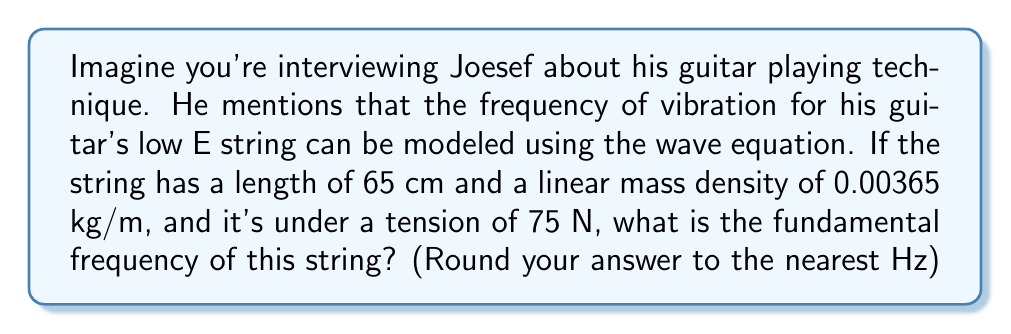Can you solve this math problem? Let's approach this step-by-step using the wave equation for a vibrating string:

1) The wave equation for a vibrating string is:

   $$\frac{\partial^2 y}{\partial t^2} = v^2 \frac{\partial^2 y}{\partial x^2}$$

   where $v$ is the wave speed.

2) The wave speed $v$ is given by:

   $$v = \sqrt{\frac{T}{\mu}}$$

   where $T$ is the tension and $\mu$ is the linear mass density.

3) Let's calculate $v$:
   
   $$v = \sqrt{\frac{75}{0.00365}} = 143.28 \text{ m/s}$$

4) The fundamental frequency $f$ of a vibrating string is given by:

   $$f = \frac{v}{2L}$$

   where $L$ is the length of the string.

5) Plugging in our values:

   $$f = \frac{143.28}{2(0.65)} = 110.22 \text{ Hz}$$

6) Rounding to the nearest Hz:

   $$f \approx 110 \text{ Hz}$$

This frequency corresponds to the note A2, which is indeed the pitch of the low E string on a guitar tuned down one whole step, a common tuning used in some genres of music.
Answer: 110 Hz 